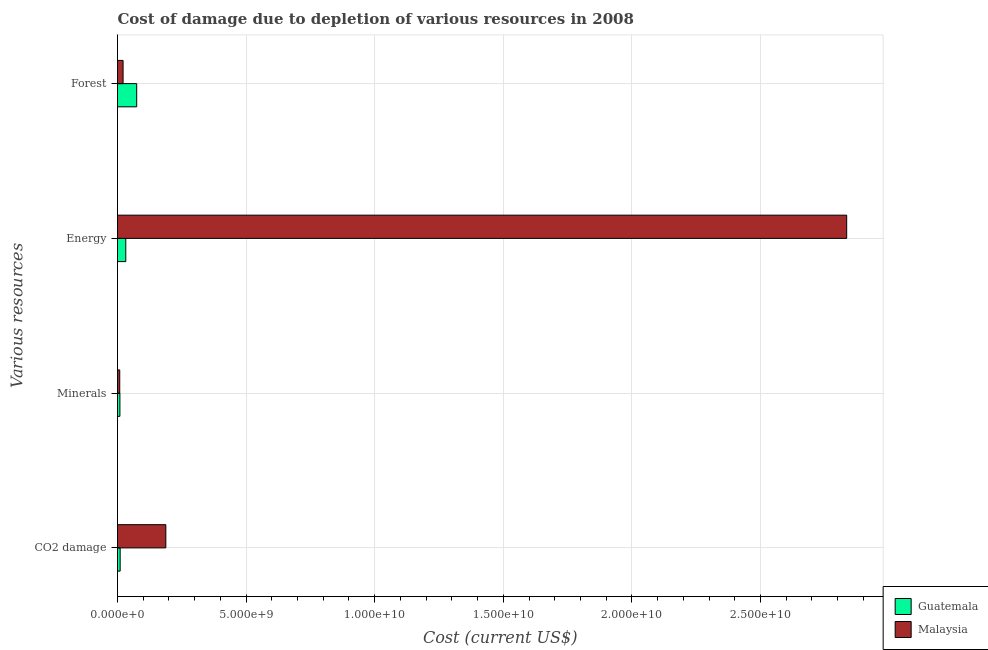How many different coloured bars are there?
Keep it short and to the point. 2. Are the number of bars per tick equal to the number of legend labels?
Provide a short and direct response. Yes. How many bars are there on the 1st tick from the bottom?
Your response must be concise. 2. What is the label of the 1st group of bars from the top?
Your answer should be compact. Forest. What is the cost of damage due to depletion of minerals in Guatemala?
Provide a short and direct response. 9.36e+07. Across all countries, what is the maximum cost of damage due to depletion of energy?
Ensure brevity in your answer.  2.84e+1. Across all countries, what is the minimum cost of damage due to depletion of minerals?
Your answer should be very brief. 8.67e+07. In which country was the cost of damage due to depletion of energy maximum?
Your response must be concise. Malaysia. In which country was the cost of damage due to depletion of minerals minimum?
Your answer should be very brief. Malaysia. What is the total cost of damage due to depletion of coal in the graph?
Provide a short and direct response. 1.98e+09. What is the difference between the cost of damage due to depletion of coal in Guatemala and that in Malaysia?
Your response must be concise. -1.78e+09. What is the difference between the cost of damage due to depletion of coal in Malaysia and the cost of damage due to depletion of energy in Guatemala?
Offer a terse response. 1.56e+09. What is the average cost of damage due to depletion of coal per country?
Your answer should be compact. 9.91e+08. What is the difference between the cost of damage due to depletion of coal and cost of damage due to depletion of minerals in Malaysia?
Keep it short and to the point. 1.79e+09. What is the ratio of the cost of damage due to depletion of coal in Guatemala to that in Malaysia?
Your response must be concise. 0.05. What is the difference between the highest and the second highest cost of damage due to depletion of coal?
Make the answer very short. 1.78e+09. What is the difference between the highest and the lowest cost of damage due to depletion of coal?
Make the answer very short. 1.78e+09. What does the 2nd bar from the top in Minerals represents?
Keep it short and to the point. Guatemala. What does the 2nd bar from the bottom in Energy represents?
Your answer should be very brief. Malaysia. How many bars are there?
Offer a terse response. 8. Does the graph contain grids?
Keep it short and to the point. Yes. Where does the legend appear in the graph?
Your response must be concise. Bottom right. What is the title of the graph?
Provide a succinct answer. Cost of damage due to depletion of various resources in 2008 . What is the label or title of the X-axis?
Provide a short and direct response. Cost (current US$). What is the label or title of the Y-axis?
Your answer should be very brief. Various resources. What is the Cost (current US$) in Guatemala in CO2 damage?
Ensure brevity in your answer.  1.03e+08. What is the Cost (current US$) of Malaysia in CO2 damage?
Offer a very short reply. 1.88e+09. What is the Cost (current US$) in Guatemala in Minerals?
Keep it short and to the point. 9.36e+07. What is the Cost (current US$) in Malaysia in Minerals?
Keep it short and to the point. 8.67e+07. What is the Cost (current US$) in Guatemala in Energy?
Your answer should be very brief. 3.22e+08. What is the Cost (current US$) in Malaysia in Energy?
Keep it short and to the point. 2.84e+1. What is the Cost (current US$) of Guatemala in Forest?
Offer a terse response. 7.47e+08. What is the Cost (current US$) of Malaysia in Forest?
Offer a very short reply. 2.17e+08. Across all Various resources, what is the maximum Cost (current US$) of Guatemala?
Your answer should be compact. 7.47e+08. Across all Various resources, what is the maximum Cost (current US$) of Malaysia?
Provide a succinct answer. 2.84e+1. Across all Various resources, what is the minimum Cost (current US$) in Guatemala?
Make the answer very short. 9.36e+07. Across all Various resources, what is the minimum Cost (current US$) of Malaysia?
Offer a terse response. 8.67e+07. What is the total Cost (current US$) of Guatemala in the graph?
Offer a very short reply. 1.27e+09. What is the total Cost (current US$) of Malaysia in the graph?
Offer a very short reply. 3.05e+1. What is the difference between the Cost (current US$) of Guatemala in CO2 damage and that in Minerals?
Provide a short and direct response. 9.60e+06. What is the difference between the Cost (current US$) in Malaysia in CO2 damage and that in Minerals?
Your answer should be compact. 1.79e+09. What is the difference between the Cost (current US$) of Guatemala in CO2 damage and that in Energy?
Your response must be concise. -2.19e+08. What is the difference between the Cost (current US$) in Malaysia in CO2 damage and that in Energy?
Keep it short and to the point. -2.65e+1. What is the difference between the Cost (current US$) in Guatemala in CO2 damage and that in Forest?
Provide a succinct answer. -6.43e+08. What is the difference between the Cost (current US$) of Malaysia in CO2 damage and that in Forest?
Offer a terse response. 1.66e+09. What is the difference between the Cost (current US$) of Guatemala in Minerals and that in Energy?
Keep it short and to the point. -2.28e+08. What is the difference between the Cost (current US$) of Malaysia in Minerals and that in Energy?
Ensure brevity in your answer.  -2.83e+1. What is the difference between the Cost (current US$) of Guatemala in Minerals and that in Forest?
Your answer should be compact. -6.53e+08. What is the difference between the Cost (current US$) of Malaysia in Minerals and that in Forest?
Give a very brief answer. -1.30e+08. What is the difference between the Cost (current US$) in Guatemala in Energy and that in Forest?
Ensure brevity in your answer.  -4.25e+08. What is the difference between the Cost (current US$) of Malaysia in Energy and that in Forest?
Provide a short and direct response. 2.81e+1. What is the difference between the Cost (current US$) of Guatemala in CO2 damage and the Cost (current US$) of Malaysia in Minerals?
Make the answer very short. 1.65e+07. What is the difference between the Cost (current US$) in Guatemala in CO2 damage and the Cost (current US$) in Malaysia in Energy?
Offer a terse response. -2.82e+1. What is the difference between the Cost (current US$) of Guatemala in CO2 damage and the Cost (current US$) of Malaysia in Forest?
Make the answer very short. -1.13e+08. What is the difference between the Cost (current US$) in Guatemala in Minerals and the Cost (current US$) in Malaysia in Energy?
Your answer should be very brief. -2.83e+1. What is the difference between the Cost (current US$) in Guatemala in Minerals and the Cost (current US$) in Malaysia in Forest?
Make the answer very short. -1.23e+08. What is the difference between the Cost (current US$) of Guatemala in Energy and the Cost (current US$) of Malaysia in Forest?
Make the answer very short. 1.05e+08. What is the average Cost (current US$) of Guatemala per Various resources?
Make the answer very short. 3.16e+08. What is the average Cost (current US$) in Malaysia per Various resources?
Your answer should be compact. 7.63e+09. What is the difference between the Cost (current US$) of Guatemala and Cost (current US$) of Malaysia in CO2 damage?
Your answer should be compact. -1.78e+09. What is the difference between the Cost (current US$) in Guatemala and Cost (current US$) in Malaysia in Minerals?
Your answer should be very brief. 6.90e+06. What is the difference between the Cost (current US$) in Guatemala and Cost (current US$) in Malaysia in Energy?
Ensure brevity in your answer.  -2.80e+1. What is the difference between the Cost (current US$) of Guatemala and Cost (current US$) of Malaysia in Forest?
Your answer should be compact. 5.30e+08. What is the ratio of the Cost (current US$) of Guatemala in CO2 damage to that in Minerals?
Make the answer very short. 1.1. What is the ratio of the Cost (current US$) in Malaysia in CO2 damage to that in Minerals?
Your answer should be very brief. 21.66. What is the ratio of the Cost (current US$) in Guatemala in CO2 damage to that in Energy?
Keep it short and to the point. 0.32. What is the ratio of the Cost (current US$) of Malaysia in CO2 damage to that in Energy?
Give a very brief answer. 0.07. What is the ratio of the Cost (current US$) of Guatemala in CO2 damage to that in Forest?
Ensure brevity in your answer.  0.14. What is the ratio of the Cost (current US$) of Malaysia in CO2 damage to that in Forest?
Make the answer very short. 8.67. What is the ratio of the Cost (current US$) of Guatemala in Minerals to that in Energy?
Ensure brevity in your answer.  0.29. What is the ratio of the Cost (current US$) of Malaysia in Minerals to that in Energy?
Keep it short and to the point. 0. What is the ratio of the Cost (current US$) of Guatemala in Minerals to that in Forest?
Provide a succinct answer. 0.13. What is the ratio of the Cost (current US$) of Malaysia in Minerals to that in Forest?
Ensure brevity in your answer.  0.4. What is the ratio of the Cost (current US$) of Guatemala in Energy to that in Forest?
Offer a very short reply. 0.43. What is the ratio of the Cost (current US$) in Malaysia in Energy to that in Forest?
Keep it short and to the point. 130.87. What is the difference between the highest and the second highest Cost (current US$) in Guatemala?
Offer a very short reply. 4.25e+08. What is the difference between the highest and the second highest Cost (current US$) of Malaysia?
Make the answer very short. 2.65e+1. What is the difference between the highest and the lowest Cost (current US$) in Guatemala?
Your answer should be compact. 6.53e+08. What is the difference between the highest and the lowest Cost (current US$) of Malaysia?
Give a very brief answer. 2.83e+1. 